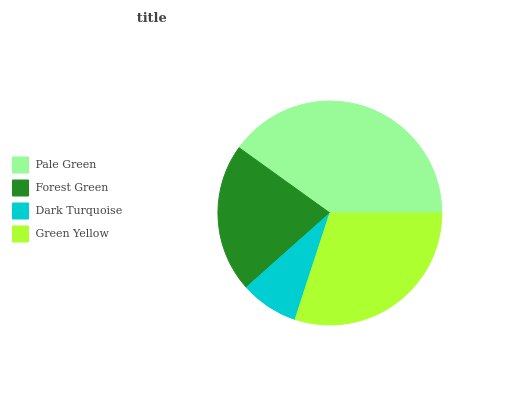Is Dark Turquoise the minimum?
Answer yes or no. Yes. Is Pale Green the maximum?
Answer yes or no. Yes. Is Forest Green the minimum?
Answer yes or no. No. Is Forest Green the maximum?
Answer yes or no. No. Is Pale Green greater than Forest Green?
Answer yes or no. Yes. Is Forest Green less than Pale Green?
Answer yes or no. Yes. Is Forest Green greater than Pale Green?
Answer yes or no. No. Is Pale Green less than Forest Green?
Answer yes or no. No. Is Green Yellow the high median?
Answer yes or no. Yes. Is Forest Green the low median?
Answer yes or no. Yes. Is Pale Green the high median?
Answer yes or no. No. Is Green Yellow the low median?
Answer yes or no. No. 